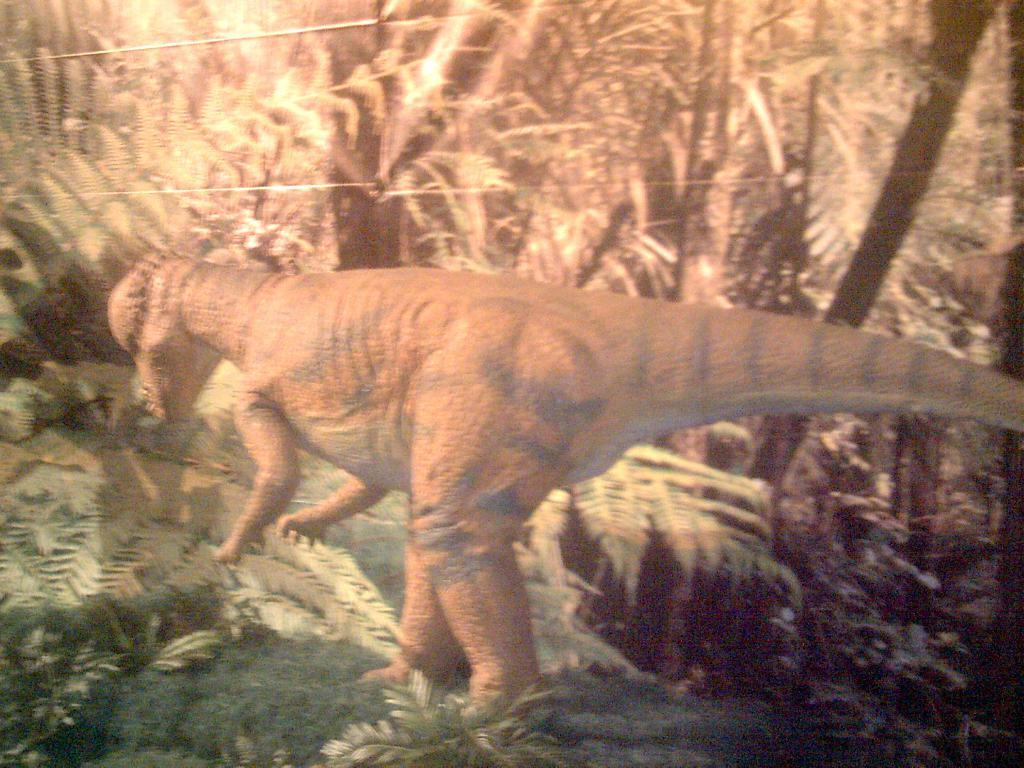What is the main subject of the image? There is a dinosaur in the image. What other elements can be seen in the image besides the dinosaur? There are plants and trees in the image. What causes the dinosaur to feel shame in the image? There is no indication of shame or any emotions in the image; it simply depicts a dinosaur and some plants and trees. 